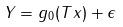<formula> <loc_0><loc_0><loc_500><loc_500>Y = g _ { 0 } ( T x ) + \epsilon</formula> 